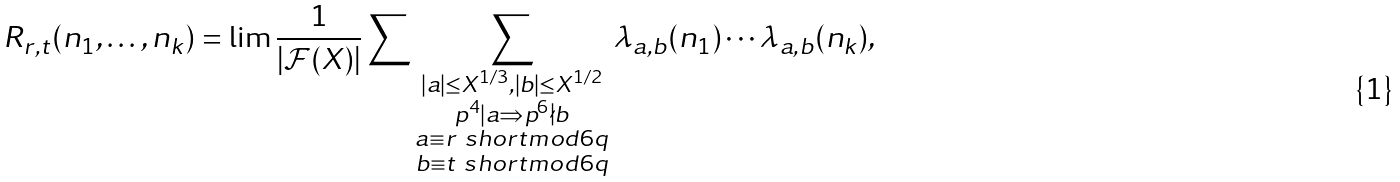<formula> <loc_0><loc_0><loc_500><loc_500>R _ { r , t } ( n _ { 1 } , \dots , n _ { k } ) = \lim \frac { 1 } { | \mathcal { F } ( X ) | } \sum \sum _ { \substack { | a | \leq X ^ { 1 / 3 } , | b | \leq X ^ { 1 / 2 } \\ p ^ { 4 } | a \Rightarrow p ^ { 6 } \nmid b \\ a \equiv r \ s h o r t m o d { 6 q } \\ b \equiv t \ s h o r t m o d { 6 q } } } \lambda _ { a , b } ( n _ { 1 } ) \cdots \lambda _ { a , b } ( n _ { k } ) ,</formula> 